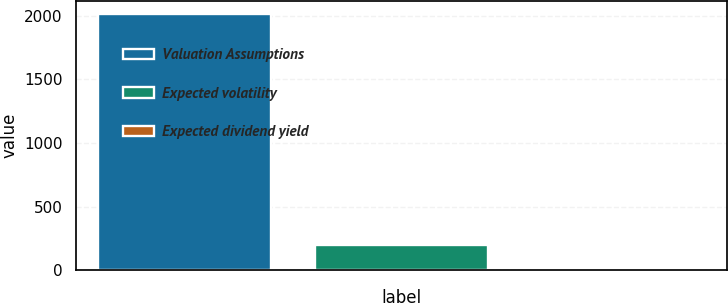<chart> <loc_0><loc_0><loc_500><loc_500><bar_chart><fcel>Valuation Assumptions<fcel>Expected volatility<fcel>Expected dividend yield<nl><fcel>2016<fcel>201.96<fcel>0.4<nl></chart> 